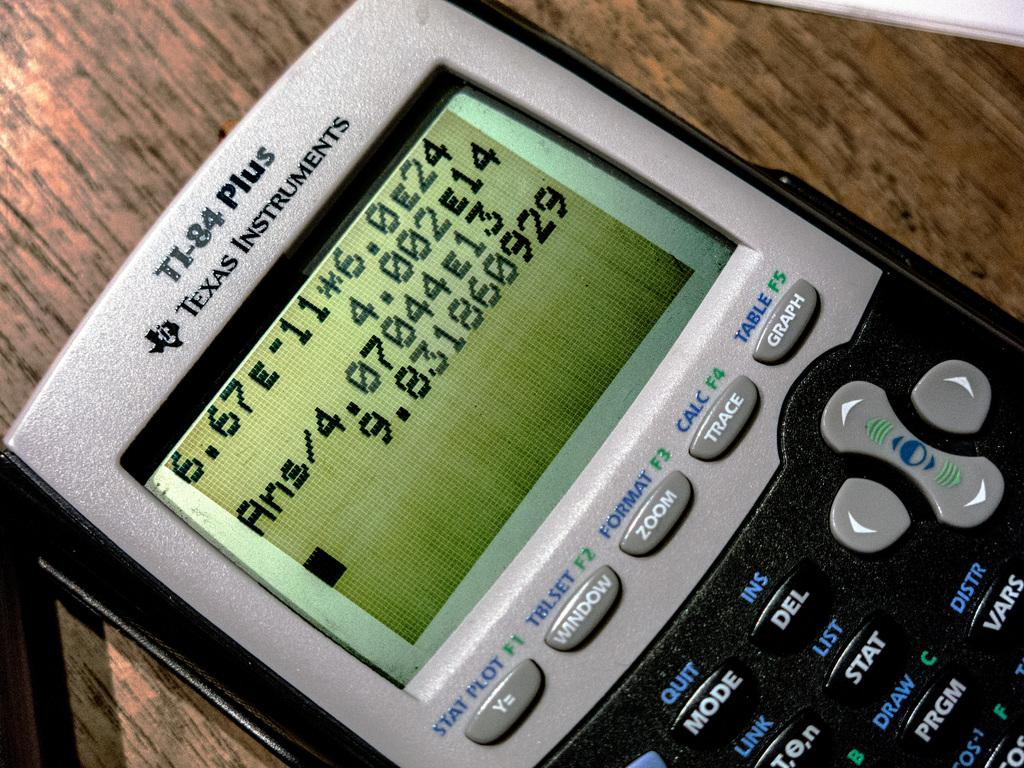Provide a one-sentence caption for the provided image. A texas instruments calculator, its model number it TI-84 plus. 